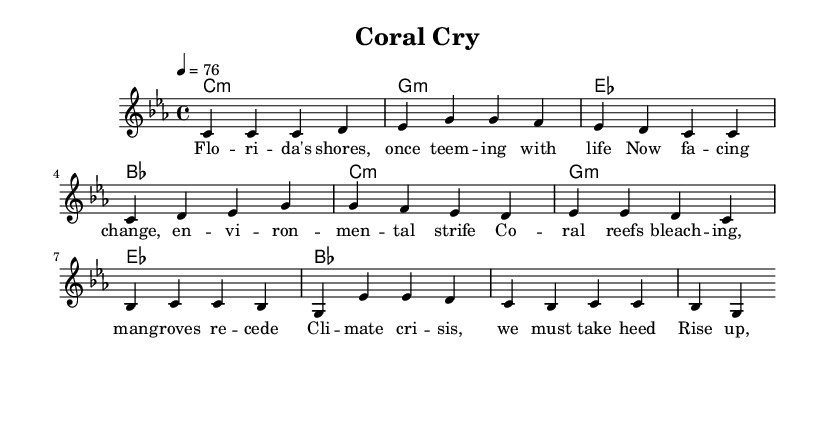What is the key signature of this music? The key signature is C minor, which can be identified by the presence of three flats in the key signature: B flat, E flat, and A flat.
Answer: C minor What is the time signature of this music? The time signature is indicated at the beginning of the score, and it shows four beats in each measure, with a quarter note receiving one beat. This can be confirmed by seeing the notation "4/4" at the start.
Answer: 4/4 What is the tempo marking for this music? The tempo marking is found in the same area as the key and time signatures; it indicates that the music should be played at a speed of 76 beats per minute. This is shown as "4 = 76" in the score.
Answer: 76 How many measures are in the verse? The verse section consists of four measures, which can be counted by looking at the vertical lines separating the music into distinct groups of beats. Each group of beats corresponds to one measure and there are four of them in the verse.
Answer: 4 What is the primary theme addressed in this song? The primary theme is the environmental impact of climate change on Florida's coastal habitats, explicitly discussed through the lyrics which mention coral bleaching and the need for protection.
Answer: Climate change How many chords are used in the harmony section? The harmony section uses a total of four distinct chords: C minor, G minor, E flat, and B flat. Each chord appears twice within the chord progression, confirming their presence.
Answer: 4 What genre does this piece of music belong to? The piece is identified as reggae music, which is characterized by its rhythmic style and thematic content aimed at social and environmental issues, especially relevant in the context of the lyrics and music structure shown here.
Answer: Reggae 